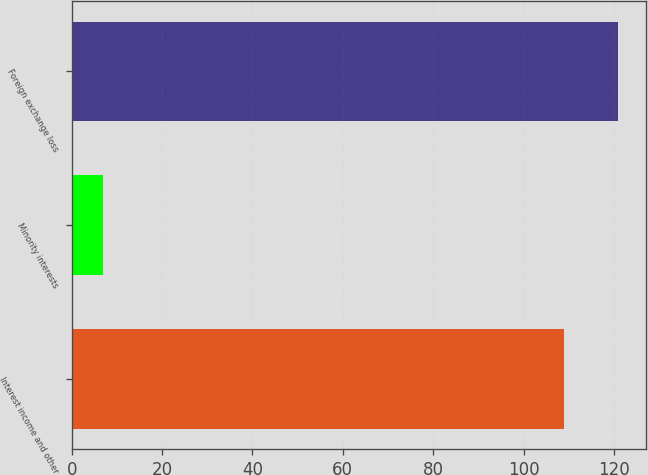Convert chart. <chart><loc_0><loc_0><loc_500><loc_500><bar_chart><fcel>Interest income and other<fcel>Minority interests<fcel>Foreign exchange loss<nl><fcel>109<fcel>7<fcel>121<nl></chart> 